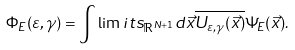<formula> <loc_0><loc_0><loc_500><loc_500>\Phi _ { E } ( \varepsilon , \gamma ) = \int \lim i t s _ { \mathbb { R } ^ { N + 1 } } d \vec { x } \overline { U _ { \varepsilon , \gamma } ( \vec { x } ) } \Psi _ { E } ( \vec { x } ) .</formula> 